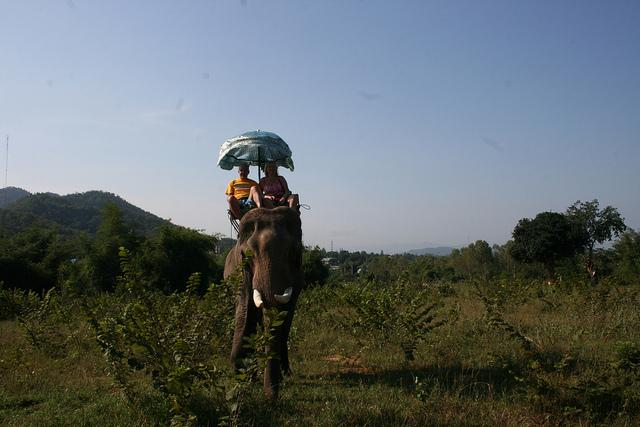What is the umbrella used to block? Please explain your reasoning. sun. It helps keep them cooler and the sun out. 